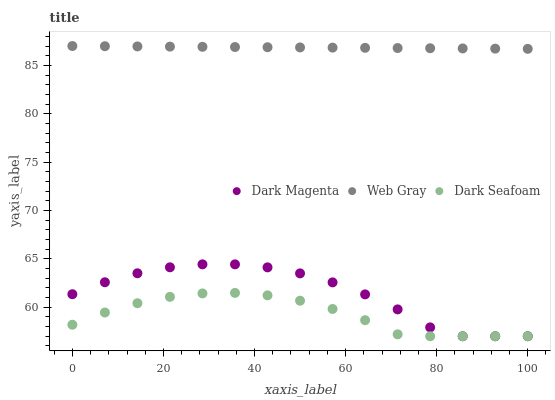Does Dark Seafoam have the minimum area under the curve?
Answer yes or no. Yes. Does Web Gray have the maximum area under the curve?
Answer yes or no. Yes. Does Dark Magenta have the minimum area under the curve?
Answer yes or no. No. Does Dark Magenta have the maximum area under the curve?
Answer yes or no. No. Is Web Gray the smoothest?
Answer yes or no. Yes. Is Dark Magenta the roughest?
Answer yes or no. Yes. Is Dark Magenta the smoothest?
Answer yes or no. No. Is Web Gray the roughest?
Answer yes or no. No. Does Dark Seafoam have the lowest value?
Answer yes or no. Yes. Does Web Gray have the lowest value?
Answer yes or no. No. Does Web Gray have the highest value?
Answer yes or no. Yes. Does Dark Magenta have the highest value?
Answer yes or no. No. Is Dark Seafoam less than Web Gray?
Answer yes or no. Yes. Is Web Gray greater than Dark Magenta?
Answer yes or no. Yes. Does Dark Seafoam intersect Dark Magenta?
Answer yes or no. Yes. Is Dark Seafoam less than Dark Magenta?
Answer yes or no. No. Is Dark Seafoam greater than Dark Magenta?
Answer yes or no. No. Does Dark Seafoam intersect Web Gray?
Answer yes or no. No. 